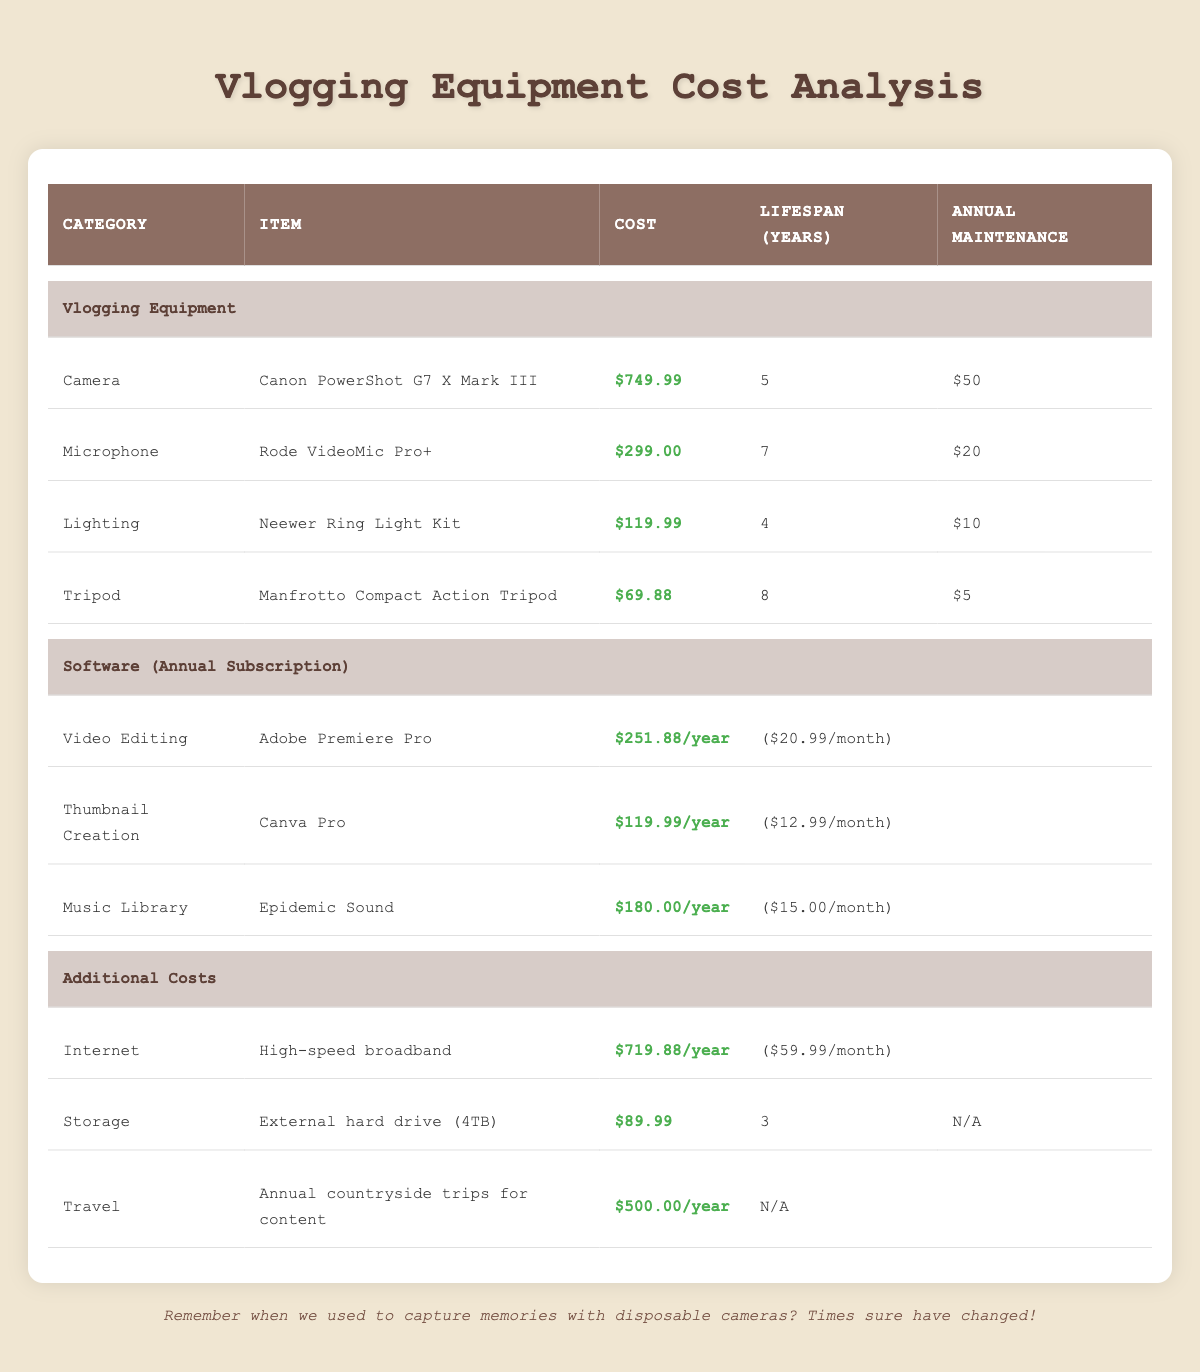What is the cost of the Canon PowerShot G7 X Mark III? The table lists the cost of the Canon PowerShot G7 X Mark III under the "Camera" category, where it is shown as $749.99.
Answer: $749.99 How long does the Rode VideoMic Pro+ last? The lifespan of the Rode VideoMic Pro+ is indicated in the "Lifespan (Years)" column of its row, which shows it lasts for 7 years.
Answer: 7 years What is the total annual cost of using the software items listed? To find the total annual cost, we sum the annual costs of Adobe Premiere Pro ($251.88), Canva Pro ($119.99), and Epidemic Sound ($180.00). Total = 251.88 + 119.99 + 180.00 = $551.87.
Answer: $551.87 Is the annual maintenance cost for the Neewer Ring Light Kit higher than that of the Manfrotto Compact Action Tripod? The annual maintenance cost for the Neewer Ring Light Kit is $10, while for the Manfrotto Compact Action Tripod it is $5. Since $10 is greater than $5, the statement is true.
Answer: Yes What is the lifespan of the external hard drive and how much does it cost per year? The external hard drive has a lifespan of 3 years and costs $89.99. To find the annual cost, we divide the one-time cost by the lifespan: $89.99 / 3 = approximately $29.99 per year.
Answer: Approximately $29.99 per year 